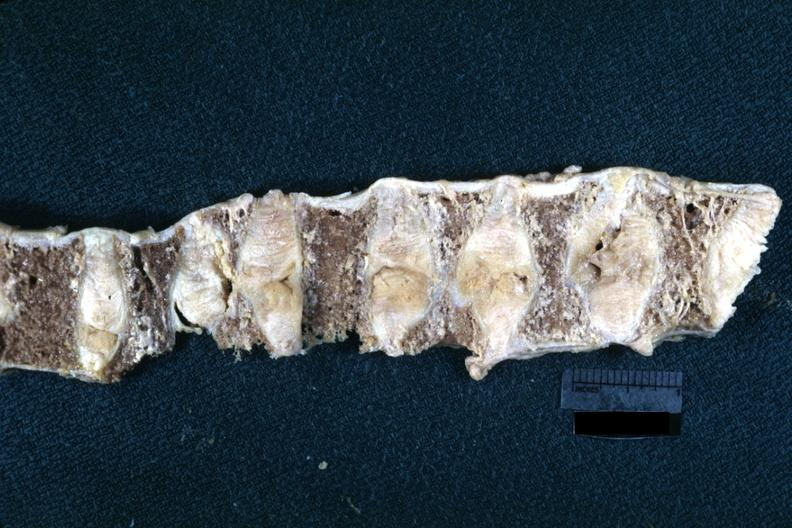s fixed tissue lateral view of vertebral bodies with many collapsed case of rheumatoid arthritis?
Answer the question using a single word or phrase. Yes 